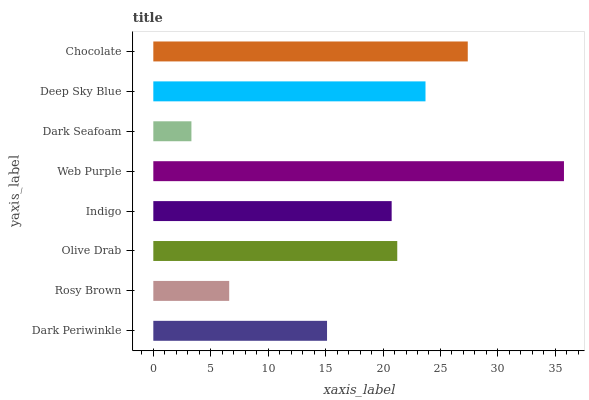Is Dark Seafoam the minimum?
Answer yes or no. Yes. Is Web Purple the maximum?
Answer yes or no. Yes. Is Rosy Brown the minimum?
Answer yes or no. No. Is Rosy Brown the maximum?
Answer yes or no. No. Is Dark Periwinkle greater than Rosy Brown?
Answer yes or no. Yes. Is Rosy Brown less than Dark Periwinkle?
Answer yes or no. Yes. Is Rosy Brown greater than Dark Periwinkle?
Answer yes or no. No. Is Dark Periwinkle less than Rosy Brown?
Answer yes or no. No. Is Olive Drab the high median?
Answer yes or no. Yes. Is Indigo the low median?
Answer yes or no. Yes. Is Chocolate the high median?
Answer yes or no. No. Is Olive Drab the low median?
Answer yes or no. No. 